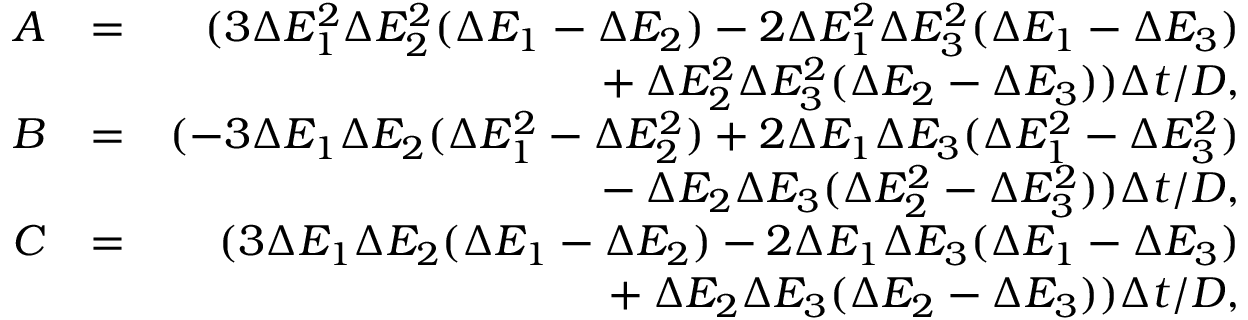<formula> <loc_0><loc_0><loc_500><loc_500>\begin{array} { r l r } { A } & { = } & { ( 3 \Delta E _ { 1 } ^ { 2 } \Delta E _ { 2 } ^ { 2 } ( \Delta E _ { 1 } - \Delta E _ { 2 } ) - 2 \Delta E _ { 1 } ^ { 2 } \Delta E _ { 3 } ^ { 2 } ( \Delta E _ { 1 } - \Delta E _ { 3 } ) \strut } \\ & { \strut + \Delta E _ { 2 } ^ { 2 } \Delta E _ { 3 } ^ { 2 } ( \Delta E _ { 2 } - \Delta E _ { 3 } ) ) \Delta t / D , } \\ { B } & { = } & { ( - 3 \Delta E _ { 1 } \Delta E _ { 2 } ( \Delta E _ { 1 } ^ { 2 } - \Delta E _ { 2 } ^ { 2 } ) + 2 \Delta E _ { 1 } \Delta E _ { 3 } ( \Delta E _ { 1 } ^ { 2 } - \Delta E _ { 3 } ^ { 2 } ) \strut } \\ & { \strut - \Delta E _ { 2 } \Delta E _ { 3 } ( \Delta E _ { 2 } ^ { 2 } - \Delta E _ { 3 } ^ { 2 } ) ) \Delta t / D , } \\ { C } & { = } & { ( 3 \Delta E _ { 1 } \Delta E _ { 2 } ( \Delta E _ { 1 } - \Delta E _ { 2 } ) - 2 \Delta E _ { 1 } \Delta E _ { 3 } ( \Delta E _ { 1 } - \Delta E _ { 3 } ) \strut } \\ & { \strut + \Delta E _ { 2 } \Delta E _ { 3 } ( \Delta E _ { 2 } - \Delta E _ { 3 } ) ) \Delta t / D , } \end{array}</formula> 